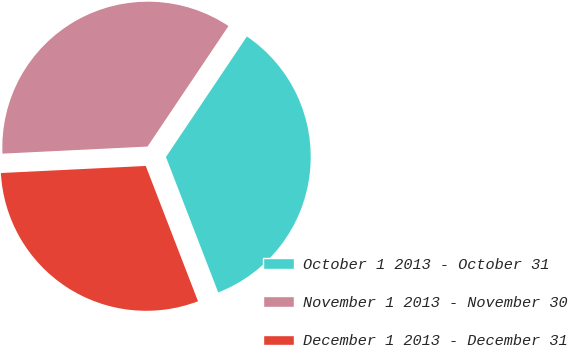<chart> <loc_0><loc_0><loc_500><loc_500><pie_chart><fcel>October 1 2013 - October 31<fcel>November 1 2013 - November 30<fcel>December 1 2013 - December 31<nl><fcel>34.72%<fcel>35.19%<fcel>30.09%<nl></chart> 